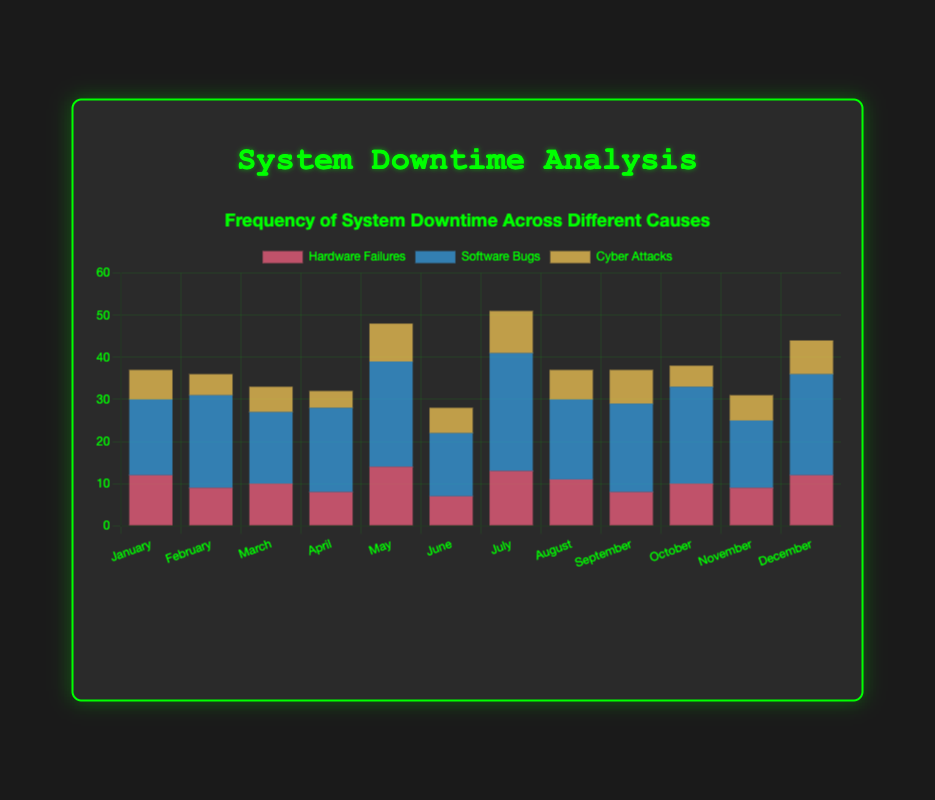Which month had the highest frequency of software bugs? By visually inspecting the different shades of blue bars representing software bugs across all months, it is evident that the tallest bar occurs in July.
Answer: July When comparing hardware failures and cyber attacks, which cause had a higher frequency of downtime in May? By looking at the stacked bar for May, the height of the red (14) portion representing hardware failures is greater than the yellow (9) portion representing cyber attacks.
Answer: Hardware Failures What is the total system downtime due to hardware failures in the first quarter (January, February, March)? Adding up the hardware failures for January, February, and March: 12 + 9 + 10 = 31.
Answer: 31 What is the average system downtime for cyber attacks per month? Summing the downtimes due to cyber attacks for all months and dividing by 12: (7 + 5 + 6 + 4 + 9 + 6 + 10 + 7 + 8 + 5 + 6 + 8) / 12 = 81 / 12 ≈ 6.75.
Answer: 6.75 Which month had the lowest total system downtime? By examining the total height of the stacked bars for each month, April has the shortest bar, indicating the lowest downtime.
Answer: April In which month did software bugs contribute to more than 50% of the total downtime? By visually inspecting the stacked bars, the month of July shows a significant portion, more than 50%, due to the blue section. The software bugs in July are 28, and the total downtime is 51 (28+13+10). The proportion is 28/51 > 0.5.
Answer: July Which cause of system downtime exhibited the most variability across months? Visually inspecting the bar lengths across months, software bugs (blue bars) have the most varied lengths compared to hardware failures (red bars) and cyber attacks (yellow bars).
Answer: Software Bugs What is the combined downtime due to software bugs and cyber attacks in August? Adding up the software bugs and cyber attacks for August: 19 (software bugs) + 7 (cyber attacks) = 26.
Answer: 26 How did the frequency of cyber attacks in December compare to February? By comparing the heights of the yellow portions of the bars for December and February, December (8) is greater than February (5).
Answer: December is higher 